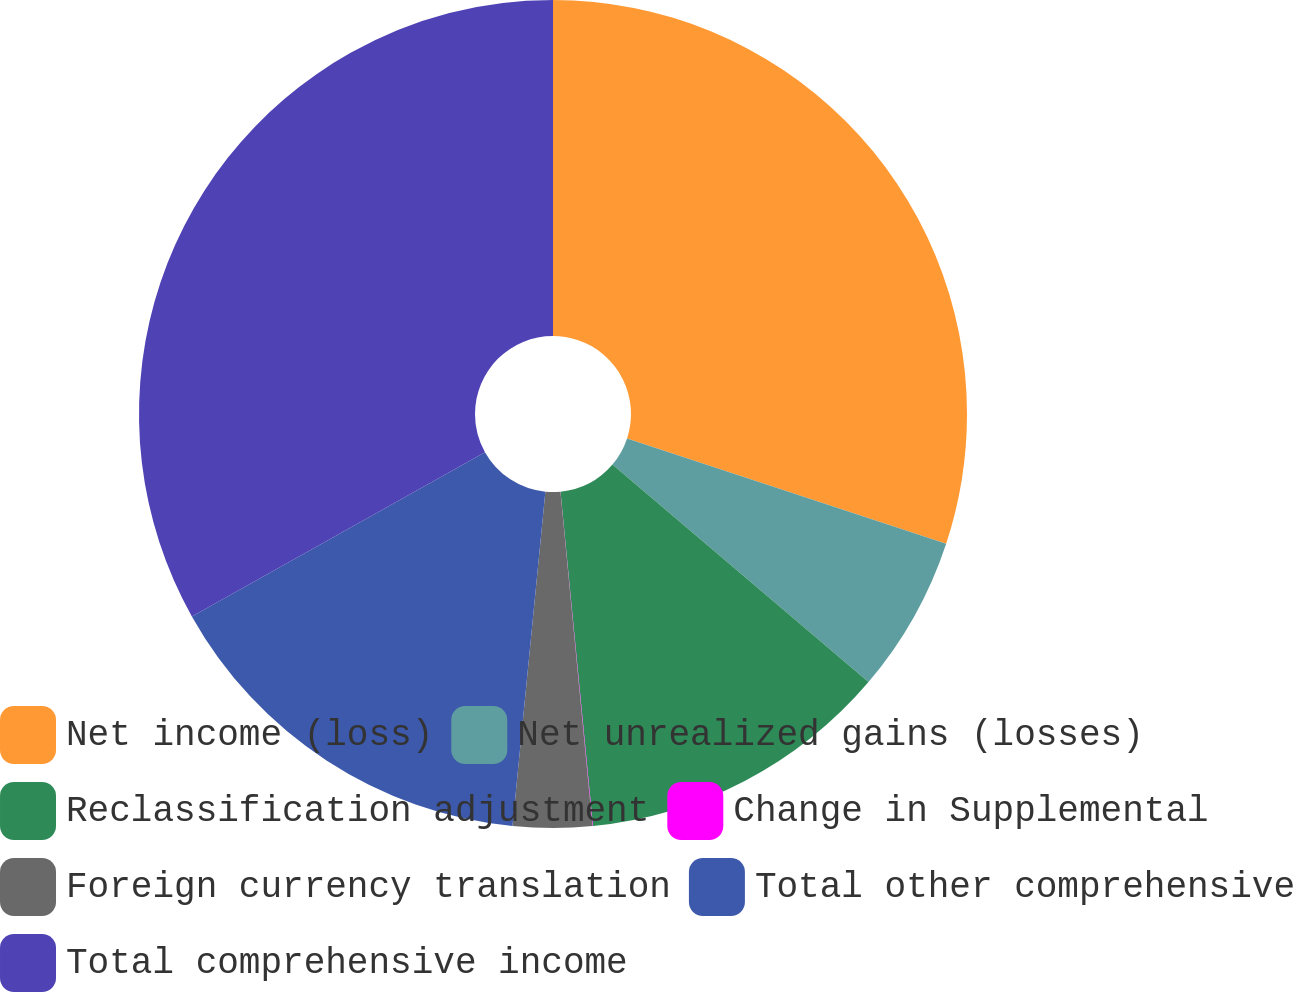<chart> <loc_0><loc_0><loc_500><loc_500><pie_chart><fcel>Net income (loss)<fcel>Net unrealized gains (losses)<fcel>Reclassification adjustment<fcel>Change in Supplemental<fcel>Foreign currency translation<fcel>Total other comprehensive<fcel>Total comprehensive income<nl><fcel>30.07%<fcel>6.14%<fcel>12.25%<fcel>0.02%<fcel>3.08%<fcel>15.31%<fcel>33.13%<nl></chart> 